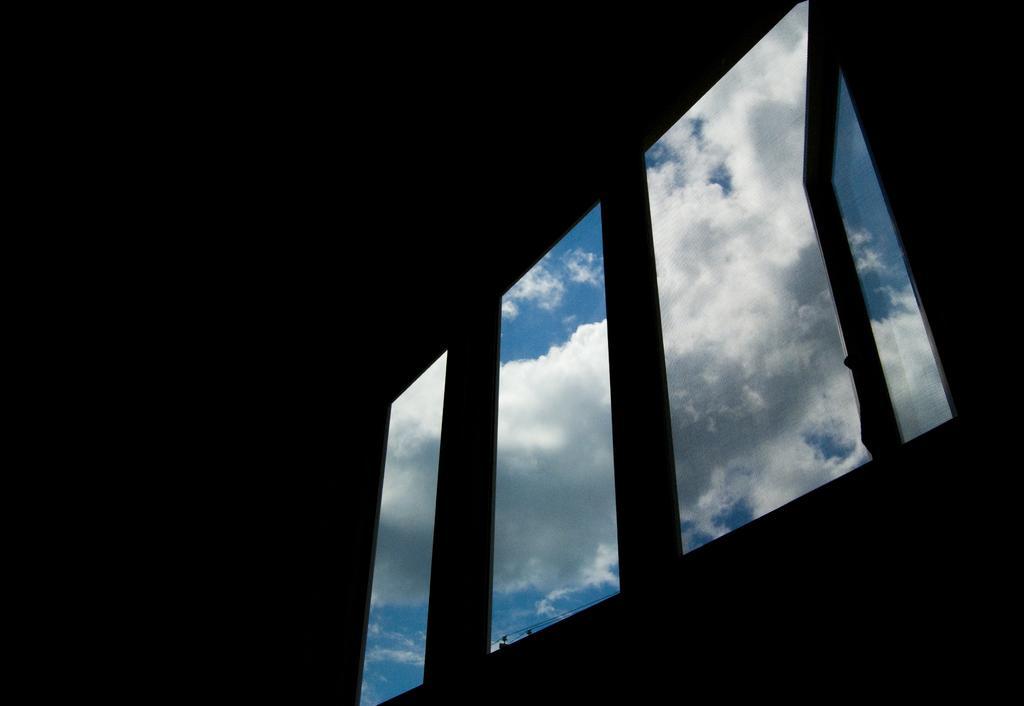Please provide a concise description of this image. In the center of the image there is window. There is sky. 